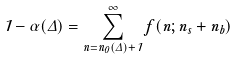Convert formula to latex. <formula><loc_0><loc_0><loc_500><loc_500>1 - \alpha ( \Delta ) = \sum ^ { \infty } _ { n = n _ { 0 } ( \Delta ) + 1 } f ( n ; n _ { s } + n _ { b } )</formula> 